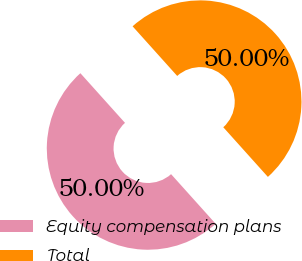Convert chart to OTSL. <chart><loc_0><loc_0><loc_500><loc_500><pie_chart><fcel>Equity compensation plans<fcel>Total<nl><fcel>50.0%<fcel>50.0%<nl></chart> 